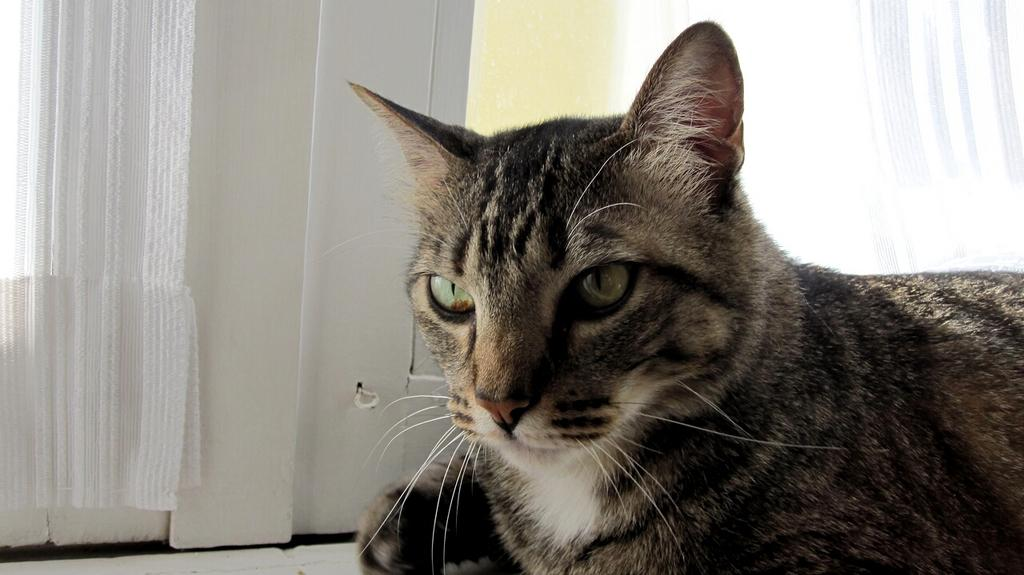What type of animal is in the image? There is a cat in the image. What colors can be seen on the cat? The cat has brown, black, and white colors. What can be seen in the background of the image? There are white curtains, windows, and a wall in the background of the image. What type of food is the cat eating in the image? There is no food visible in the image, and the cat is not shown eating anything. What impulse might the cat have in the image? The image does not provide any information about the cat's impulses or emotions. 